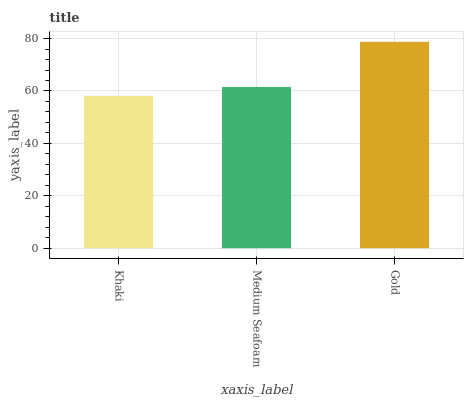Is Khaki the minimum?
Answer yes or no. Yes. Is Gold the maximum?
Answer yes or no. Yes. Is Medium Seafoam the minimum?
Answer yes or no. No. Is Medium Seafoam the maximum?
Answer yes or no. No. Is Medium Seafoam greater than Khaki?
Answer yes or no. Yes. Is Khaki less than Medium Seafoam?
Answer yes or no. Yes. Is Khaki greater than Medium Seafoam?
Answer yes or no. No. Is Medium Seafoam less than Khaki?
Answer yes or no. No. Is Medium Seafoam the high median?
Answer yes or no. Yes. Is Medium Seafoam the low median?
Answer yes or no. Yes. Is Khaki the high median?
Answer yes or no. No. Is Khaki the low median?
Answer yes or no. No. 